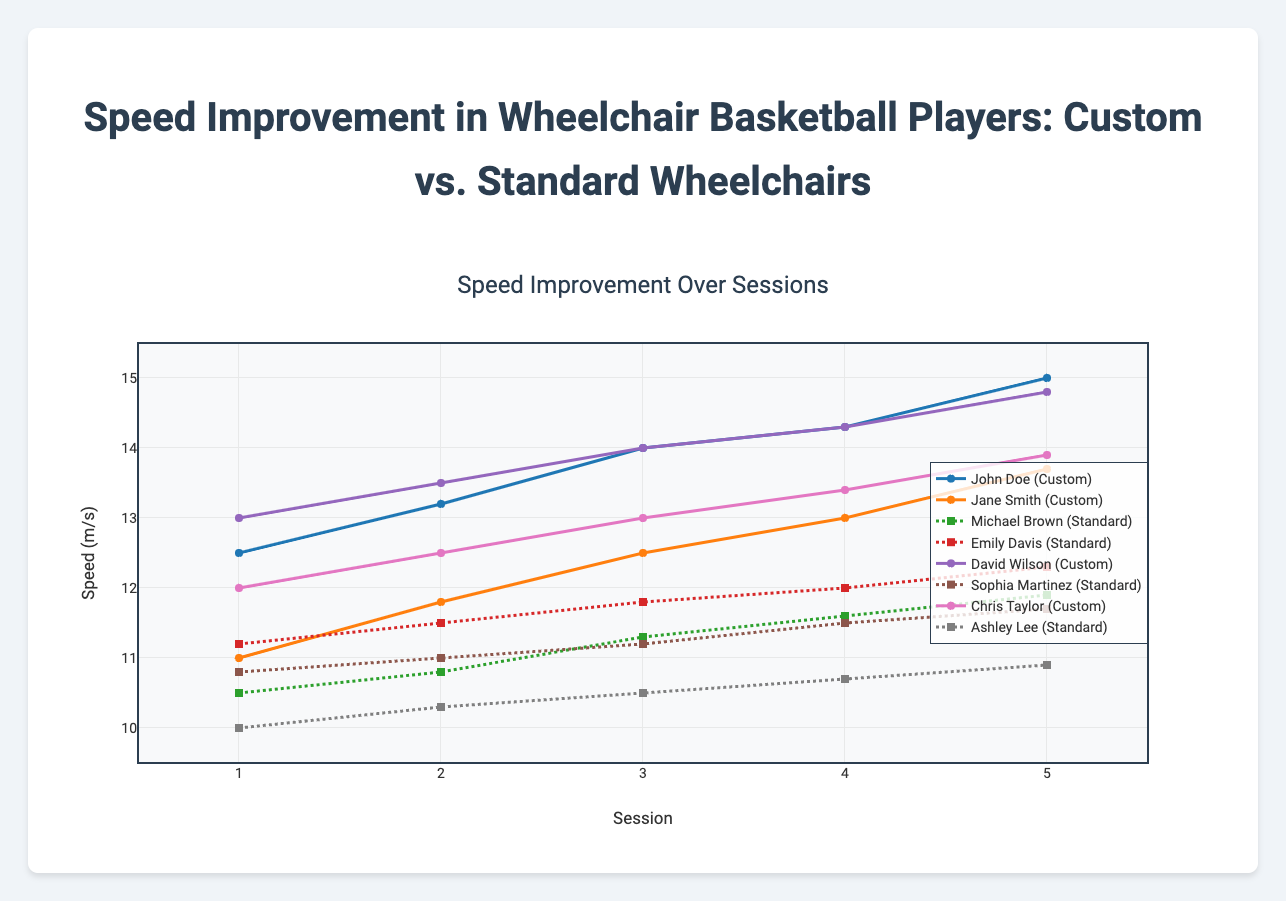What type of wheelchair does John Doe use? The legend of the plot indicates that John Doe's data is represented by a line and marker with specific visual attributes, which are consistent with the type 'Custom'.
Answer: Custom Which player shows the greatest speed improvement over the sessions? To determine this, calculate the difference between the speed in session 5 and session 1 for each player. John Doe has 15.0 - 12.5 = 2.5 m/s, Jane Smith has 13.7 - 11.0 = 2.7 m/s, Michael Brown has 11.9 - 10.5 = 1.4 m/s, Emily Davis has 12.3 - 11.2 = 1.1 m/s, David Wilson has 14.8 - 13.0 = 1.8 m/s, Sophia Martinez has 11.7 - 10.8 = 0.9 m/s, Chris Taylor has 13.9 - 12.0 = 1.9 m/s, and Ashley Lee has 10.9 - 10.0 = 0.9 m/s. Jane Smith shows the greatest improvement.
Answer: Jane Smith How does the speed of players using custom wheelchairs generally compare to those using standard wheelchairs by the final session? Looking at the final session speeds, John Doe (15.0), Jane Smith (13.7), David Wilson (14.8), and Chris Taylor (13.9) are using custom wheelchairs. Their speeds are higher compared to Michael Brown (11.9), Emily Davis (12.3), Sophia Martinez (11.7), and Ashley Lee (10.9), who are using standard wheelchairs.
Answer: Custom wheelchairs generally result in higher speeds What is the average speed in session 3 for players using standard wheelchairs? Average is calculated by summing the speeds of all relevant players in session 3 and dividing by the number of those players. Michael Brown: 11.3, Emily Davis: 11.8, Sophia Martinez: 11.2, Ashley Lee: 10.5. (11.3 + 11.8 + 11.2 + 10.5) / 4 = 44.8 / 4 = 11.2 m/s.
Answer: 11.2 m/s Who had the fastest recorded speed in any session, and what was it? By inspecting the highest points on the plot, John Doe reached 15.0 m/s in session 5, which is the highest speed recorded.
Answer: John Doe, 15.0 m/s Between sessions 2 and 4, which player experienced the largest improvement in speed? Calculate the speed improvement between sessions 2 and 4 for each player: John Doe: 14.3 - 13.2 = 1.1, Jane Smith: 13.0 - 11.8 = 1.2, Michael Brown: 11.6 - 10.8 = 0.8, Emily Davis: 12.0 - 11.5 = 0.5, David Wilson: 14.3 - 13.5 = 0.8, Sophia Martinez: 11.5 - 11.0 = 0.5, Chris Taylor: 13.4 - 12.5 = 0.9, Ashley Lee: 10.7 - 10.3 = 0.4. The greatest improvement is by Jane Smith.
Answer: Jane Smith How does the speed of Emily Davis in session 5 compare with Chris Taylor in session 5? Comparing the y-values for session 5, Emily Davis' speed is 12.3 m/s, while Chris Taylor's is 13.9 m/s. Chris Taylor's speed is higher.
Answer: Chris Taylor's speed is higher Which custom wheelchair player shows the least speed improvement from session 2 to session 3? Calculate the speed improvement from session 2 to session 3 for each custom wheelchair player. John Doe: 14.0 - 13.2 = 0.8, Jane Smith: 12.5 - 11.8 = 0.7, David Wilson: 14.0 - 13.5 = 0.5, Chris Taylor: 13.0 - 12.5 = 0.5. The smallest improvement is tied between David Wilson and Chris Taylor.
Answer: David Wilson and Chris Taylor What is the speed difference between the fastest and slowest standard wheelchair users in session 1? Identify the session 1 speeds for standard wheelchair users: Michael Brown (10.5), Emily Davis (11.2), Sophia Martinez (10.8), Ashley Lee (10.0). The difference between the highest (Emily Davis) and lowest (Ashley Lee) is 11.2 - 10.0 = 1.2 m/s.
Answer: 1.2 m/s 